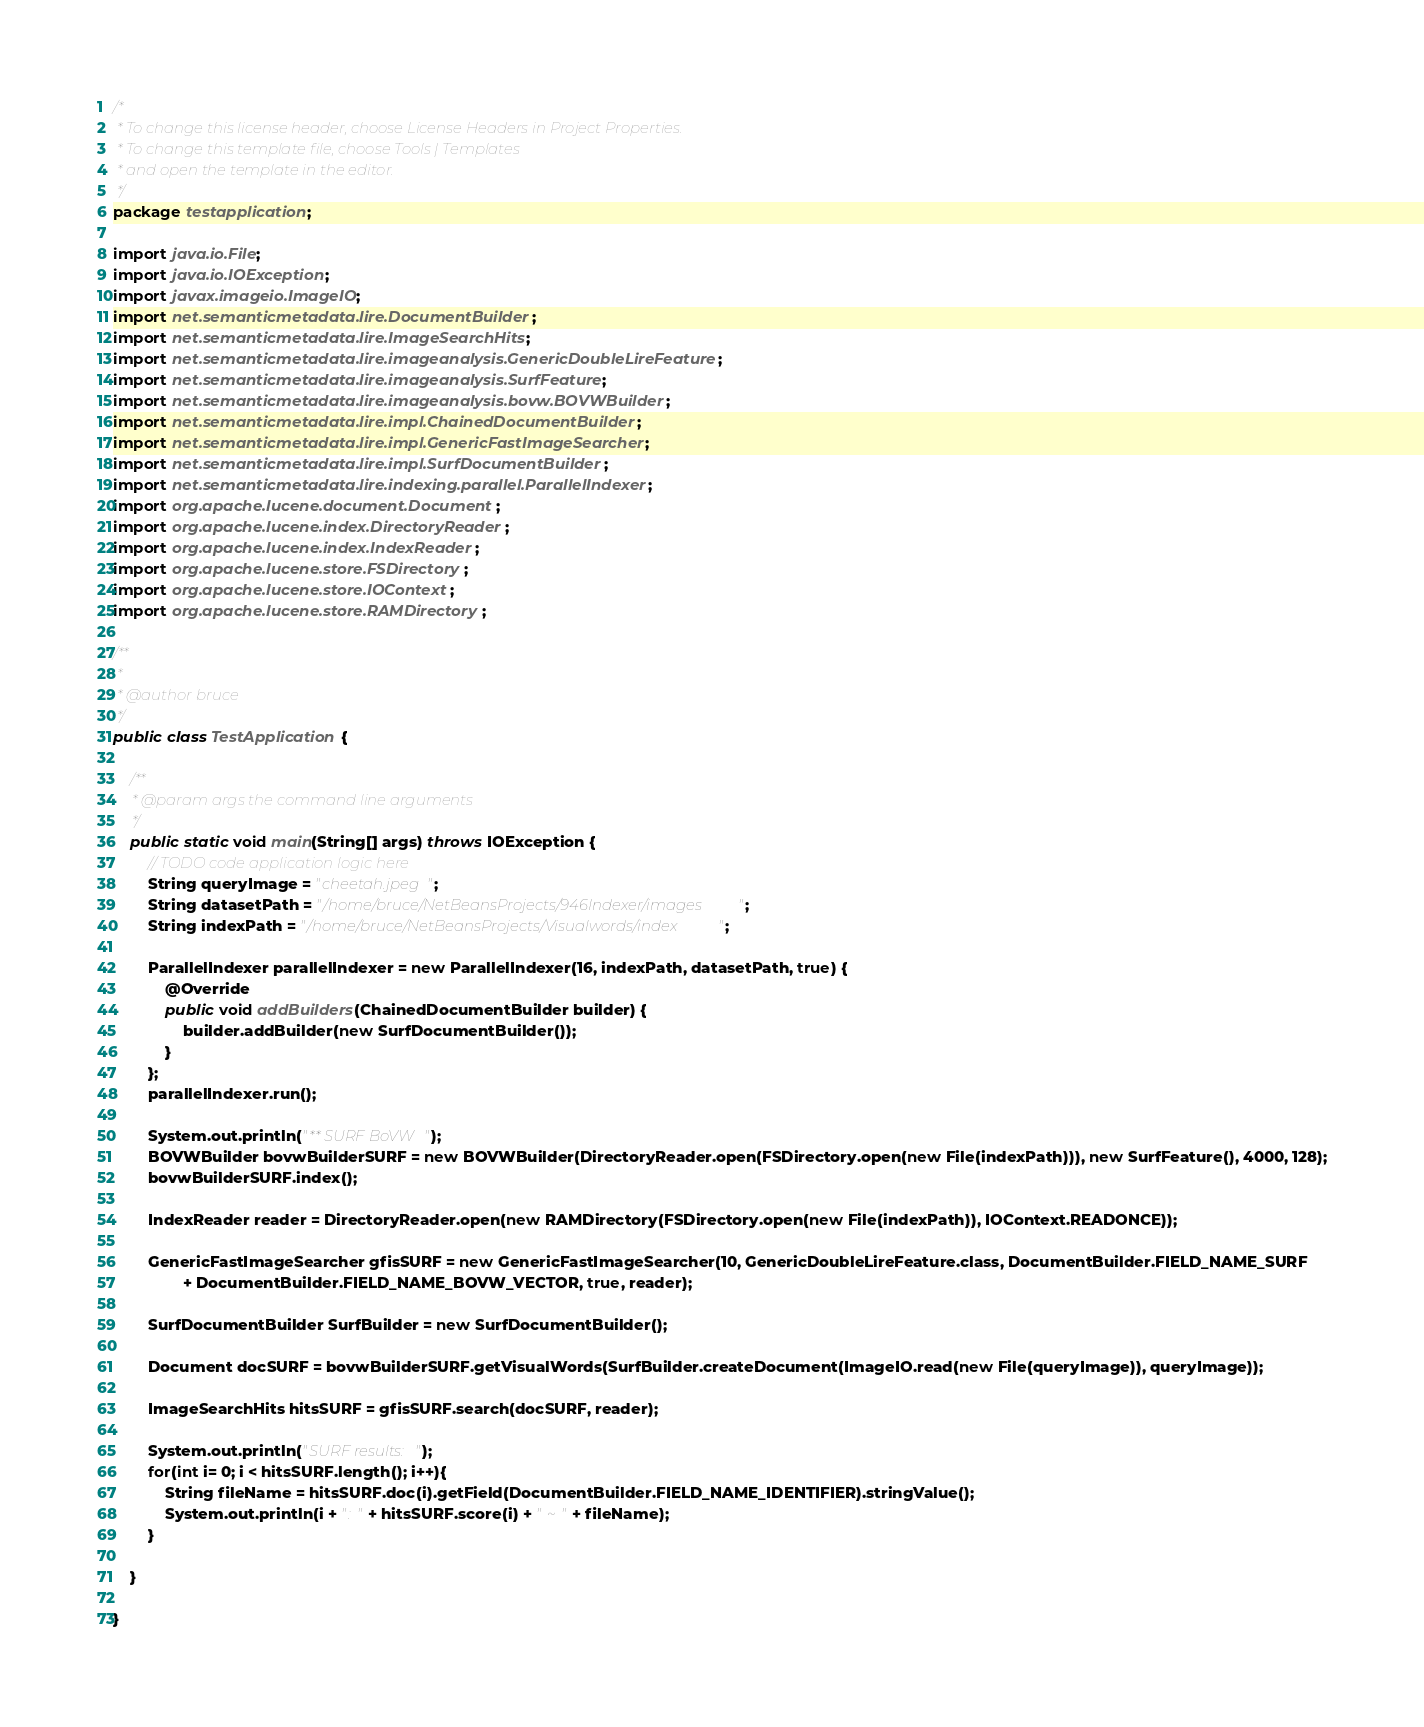Convert code to text. <code><loc_0><loc_0><loc_500><loc_500><_Java_>/*
 * To change this license header, choose License Headers in Project Properties.
 * To change this template file, choose Tools | Templates
 * and open the template in the editor.
 */
package testapplication;

import java.io.File;
import java.io.IOException;
import javax.imageio.ImageIO;
import net.semanticmetadata.lire.DocumentBuilder;
import net.semanticmetadata.lire.ImageSearchHits;
import net.semanticmetadata.lire.imageanalysis.GenericDoubleLireFeature;
import net.semanticmetadata.lire.imageanalysis.SurfFeature;
import net.semanticmetadata.lire.imageanalysis.bovw.BOVWBuilder;
import net.semanticmetadata.lire.impl.ChainedDocumentBuilder;
import net.semanticmetadata.lire.impl.GenericFastImageSearcher;
import net.semanticmetadata.lire.impl.SurfDocumentBuilder;
import net.semanticmetadata.lire.indexing.parallel.ParallelIndexer;
import org.apache.lucene.document.Document;
import org.apache.lucene.index.DirectoryReader;
import org.apache.lucene.index.IndexReader;
import org.apache.lucene.store.FSDirectory;
import org.apache.lucene.store.IOContext;
import org.apache.lucene.store.RAMDirectory;

/**
 *
 * @author bruce
 */
public class TestApplication {

    /**
     * @param args the command line arguments
     */
    public static void main(String[] args) throws IOException {
        // TODO code application logic here
        String queryImage = "cheetah.jpeg";
        String datasetPath = "/home/bruce/NetBeansProjects/946Indexer/images";
        String indexPath = "/home/bruce/NetBeansProjects/Visualwords/index";

        ParallelIndexer parallelIndexer = new ParallelIndexer(16, indexPath, datasetPath, true) {
            @Override
            public void addBuilders(ChainedDocumentBuilder builder) {
                builder.addBuilder(new SurfDocumentBuilder());
            }
        };
        parallelIndexer.run();

        System.out.println("** SURF BoVW");
        BOVWBuilder bovwBuilderSURF = new BOVWBuilder(DirectoryReader.open(FSDirectory.open(new File(indexPath))), new SurfFeature(), 4000, 128);
        bovwBuilderSURF.index();
        
        IndexReader reader = DirectoryReader.open(new RAMDirectory(FSDirectory.open(new File(indexPath)), IOContext.READONCE));

        GenericFastImageSearcher gfisSURF = new GenericFastImageSearcher(10, GenericDoubleLireFeature.class, DocumentBuilder.FIELD_NAME_SURF
                + DocumentBuilder.FIELD_NAME_BOVW_VECTOR, true, reader);
       
        SurfDocumentBuilder SurfBuilder = new SurfDocumentBuilder();
      
        Document docSURF = bovwBuilderSURF.getVisualWords(SurfBuilder.createDocument(ImageIO.read(new File(queryImage)), queryImage));
       
        ImageSearchHits hitsSURF = gfisSURF.search(docSURF, reader);
  
        System.out.println("SURF results:");
        for(int i= 0; i < hitsSURF.length(); i++){
            String fileName = hitsSURF.doc(i).getField(DocumentBuilder.FIELD_NAME_IDENTIFIER).stringValue();
            System.out.println(i + ": " + hitsSURF.score(i) + " ~ " + fileName);
        }
       
    }
    
}
</code> 